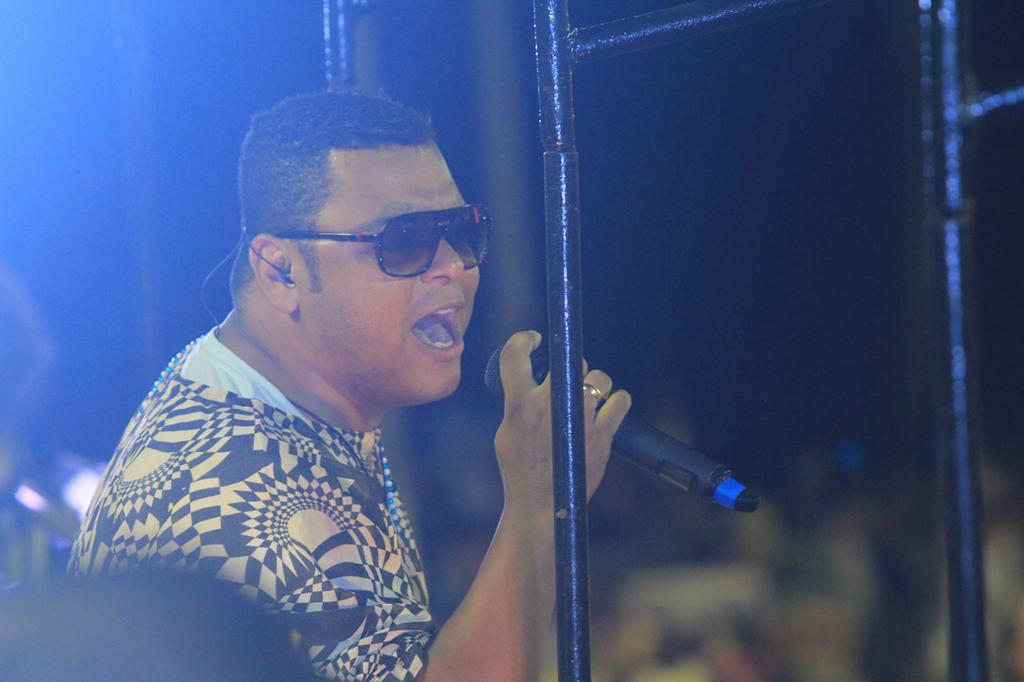Describe this image in one or two sentences. There is a man holding a microphone and wore glasses and we can see rods. Background it is dark and blur. 